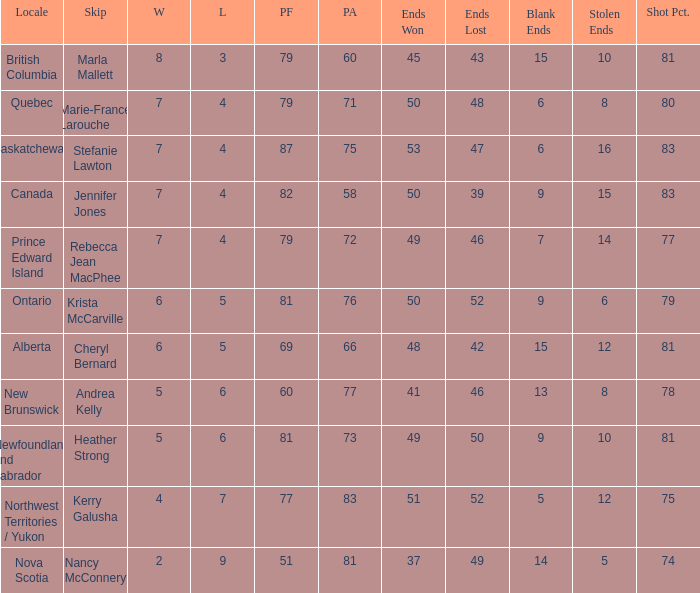What is the pf for Rebecca Jean Macphee? 79.0. 